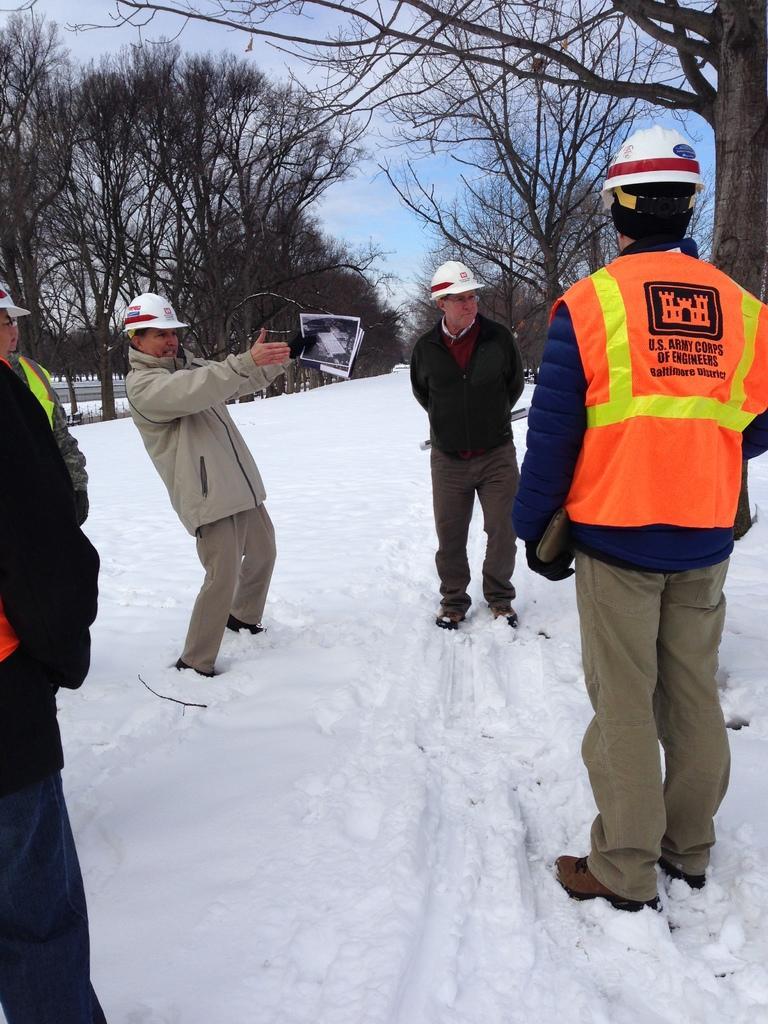Can you describe this image briefly? In this image there are few people standing in the snow by wearing the jackets and helmets. The man in the middle is holding the camera and papers. In the background there are trees. At the bottom there is snow. 